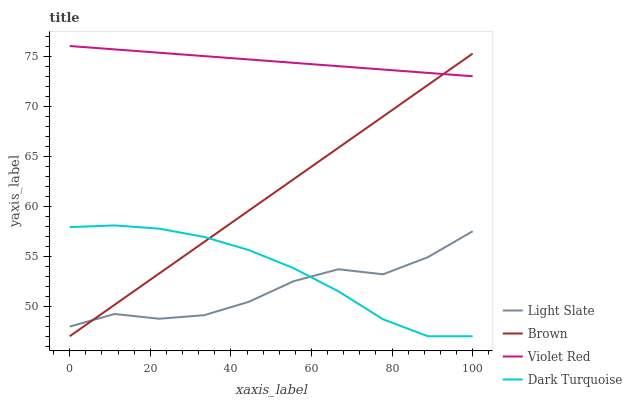Does Light Slate have the minimum area under the curve?
Answer yes or no. Yes. Does Violet Red have the maximum area under the curve?
Answer yes or no. Yes. Does Brown have the minimum area under the curve?
Answer yes or no. No. Does Brown have the maximum area under the curve?
Answer yes or no. No. Is Brown the smoothest?
Answer yes or no. Yes. Is Light Slate the roughest?
Answer yes or no. Yes. Is Violet Red the smoothest?
Answer yes or no. No. Is Violet Red the roughest?
Answer yes or no. No. Does Brown have the lowest value?
Answer yes or no. Yes. Does Violet Red have the lowest value?
Answer yes or no. No. Does Violet Red have the highest value?
Answer yes or no. Yes. Does Brown have the highest value?
Answer yes or no. No. Is Dark Turquoise less than Violet Red?
Answer yes or no. Yes. Is Violet Red greater than Dark Turquoise?
Answer yes or no. Yes. Does Brown intersect Light Slate?
Answer yes or no. Yes. Is Brown less than Light Slate?
Answer yes or no. No. Is Brown greater than Light Slate?
Answer yes or no. No. Does Dark Turquoise intersect Violet Red?
Answer yes or no. No. 